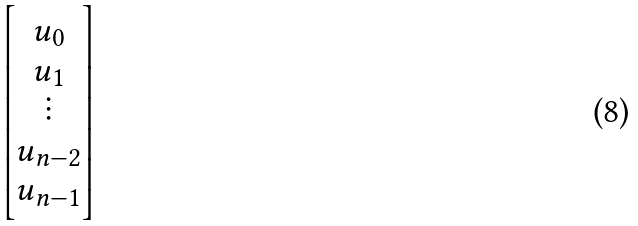<formula> <loc_0><loc_0><loc_500><loc_500>\begin{bmatrix} u _ { 0 } \\ u _ { 1 } \\ \vdots \\ u _ { n - 2 } \\ u _ { n - 1 } \end{bmatrix}</formula> 